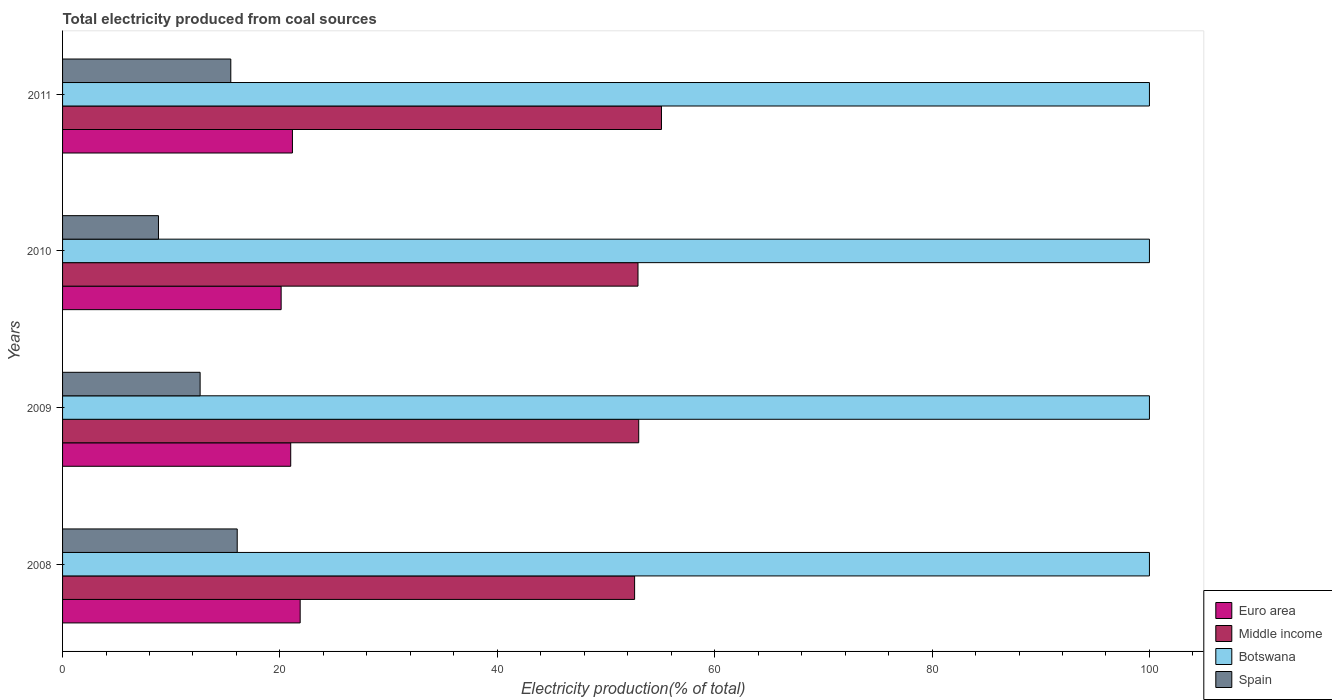Are the number of bars per tick equal to the number of legend labels?
Your answer should be compact. Yes. How many bars are there on the 1st tick from the top?
Your answer should be very brief. 4. How many bars are there on the 4th tick from the bottom?
Your response must be concise. 4. What is the label of the 3rd group of bars from the top?
Keep it short and to the point. 2009. What is the total electricity produced in Middle income in 2008?
Keep it short and to the point. 52.63. Across all years, what is the maximum total electricity produced in Botswana?
Provide a succinct answer. 100. Across all years, what is the minimum total electricity produced in Middle income?
Ensure brevity in your answer.  52.63. What is the total total electricity produced in Botswana in the graph?
Offer a terse response. 400. What is the difference between the total electricity produced in Euro area in 2008 and that in 2010?
Ensure brevity in your answer.  1.75. What is the difference between the total electricity produced in Spain in 2009 and the total electricity produced in Botswana in 2011?
Your answer should be very brief. -87.34. What is the average total electricity produced in Middle income per year?
Your response must be concise. 53.42. In the year 2011, what is the difference between the total electricity produced in Euro area and total electricity produced in Spain?
Ensure brevity in your answer.  5.67. What is the ratio of the total electricity produced in Middle income in 2010 to that in 2011?
Your response must be concise. 0.96. Is the difference between the total electricity produced in Euro area in 2009 and 2010 greater than the difference between the total electricity produced in Spain in 2009 and 2010?
Offer a terse response. No. What is the difference between the highest and the second highest total electricity produced in Euro area?
Offer a terse response. 0.71. What is the difference between the highest and the lowest total electricity produced in Spain?
Offer a terse response. 7.25. Is the sum of the total electricity produced in Middle income in 2008 and 2010 greater than the maximum total electricity produced in Euro area across all years?
Ensure brevity in your answer.  Yes. What does the 1st bar from the top in 2011 represents?
Provide a short and direct response. Spain. What does the 3rd bar from the bottom in 2008 represents?
Offer a terse response. Botswana. Is it the case that in every year, the sum of the total electricity produced in Botswana and total electricity produced in Spain is greater than the total electricity produced in Middle income?
Provide a short and direct response. Yes. How many bars are there?
Provide a short and direct response. 16. How many years are there in the graph?
Give a very brief answer. 4. Are the values on the major ticks of X-axis written in scientific E-notation?
Provide a short and direct response. No. Does the graph contain any zero values?
Keep it short and to the point. No. Does the graph contain grids?
Give a very brief answer. No. How many legend labels are there?
Your answer should be very brief. 4. What is the title of the graph?
Keep it short and to the point. Total electricity produced from coal sources. What is the label or title of the X-axis?
Offer a terse response. Electricity production(% of total). What is the Electricity production(% of total) in Euro area in 2008?
Provide a succinct answer. 21.86. What is the Electricity production(% of total) in Middle income in 2008?
Your answer should be very brief. 52.63. What is the Electricity production(% of total) of Botswana in 2008?
Make the answer very short. 100. What is the Electricity production(% of total) of Spain in 2008?
Offer a terse response. 16.07. What is the Electricity production(% of total) in Euro area in 2009?
Give a very brief answer. 20.99. What is the Electricity production(% of total) in Middle income in 2009?
Give a very brief answer. 53.01. What is the Electricity production(% of total) in Botswana in 2009?
Provide a short and direct response. 100. What is the Electricity production(% of total) of Spain in 2009?
Provide a short and direct response. 12.66. What is the Electricity production(% of total) in Euro area in 2010?
Provide a succinct answer. 20.11. What is the Electricity production(% of total) in Middle income in 2010?
Give a very brief answer. 52.94. What is the Electricity production(% of total) in Spain in 2010?
Keep it short and to the point. 8.82. What is the Electricity production(% of total) of Euro area in 2011?
Give a very brief answer. 21.15. What is the Electricity production(% of total) in Middle income in 2011?
Your response must be concise. 55.1. What is the Electricity production(% of total) of Spain in 2011?
Ensure brevity in your answer.  15.48. Across all years, what is the maximum Electricity production(% of total) of Euro area?
Provide a short and direct response. 21.86. Across all years, what is the maximum Electricity production(% of total) of Middle income?
Offer a very short reply. 55.1. Across all years, what is the maximum Electricity production(% of total) in Spain?
Offer a very short reply. 16.07. Across all years, what is the minimum Electricity production(% of total) in Euro area?
Offer a terse response. 20.11. Across all years, what is the minimum Electricity production(% of total) in Middle income?
Provide a short and direct response. 52.63. Across all years, what is the minimum Electricity production(% of total) in Botswana?
Make the answer very short. 100. Across all years, what is the minimum Electricity production(% of total) in Spain?
Keep it short and to the point. 8.82. What is the total Electricity production(% of total) in Euro area in the graph?
Offer a terse response. 84.11. What is the total Electricity production(% of total) of Middle income in the graph?
Provide a short and direct response. 213.69. What is the total Electricity production(% of total) in Botswana in the graph?
Your response must be concise. 400. What is the total Electricity production(% of total) of Spain in the graph?
Provide a short and direct response. 53.03. What is the difference between the Electricity production(% of total) of Euro area in 2008 and that in 2009?
Keep it short and to the point. 0.87. What is the difference between the Electricity production(% of total) in Middle income in 2008 and that in 2009?
Ensure brevity in your answer.  -0.38. What is the difference between the Electricity production(% of total) of Botswana in 2008 and that in 2009?
Offer a terse response. 0. What is the difference between the Electricity production(% of total) in Spain in 2008 and that in 2009?
Provide a short and direct response. 3.41. What is the difference between the Electricity production(% of total) in Euro area in 2008 and that in 2010?
Ensure brevity in your answer.  1.75. What is the difference between the Electricity production(% of total) in Middle income in 2008 and that in 2010?
Make the answer very short. -0.31. What is the difference between the Electricity production(% of total) in Botswana in 2008 and that in 2010?
Ensure brevity in your answer.  0. What is the difference between the Electricity production(% of total) in Spain in 2008 and that in 2010?
Make the answer very short. 7.25. What is the difference between the Electricity production(% of total) of Euro area in 2008 and that in 2011?
Ensure brevity in your answer.  0.71. What is the difference between the Electricity production(% of total) of Middle income in 2008 and that in 2011?
Your response must be concise. -2.47. What is the difference between the Electricity production(% of total) of Spain in 2008 and that in 2011?
Keep it short and to the point. 0.59. What is the difference between the Electricity production(% of total) in Euro area in 2009 and that in 2010?
Offer a terse response. 0.88. What is the difference between the Electricity production(% of total) of Middle income in 2009 and that in 2010?
Ensure brevity in your answer.  0.07. What is the difference between the Electricity production(% of total) of Spain in 2009 and that in 2010?
Offer a very short reply. 3.83. What is the difference between the Electricity production(% of total) in Euro area in 2009 and that in 2011?
Offer a very short reply. -0.16. What is the difference between the Electricity production(% of total) in Middle income in 2009 and that in 2011?
Make the answer very short. -2.09. What is the difference between the Electricity production(% of total) of Botswana in 2009 and that in 2011?
Provide a short and direct response. 0. What is the difference between the Electricity production(% of total) of Spain in 2009 and that in 2011?
Your answer should be very brief. -2.82. What is the difference between the Electricity production(% of total) in Euro area in 2010 and that in 2011?
Provide a succinct answer. -1.04. What is the difference between the Electricity production(% of total) in Middle income in 2010 and that in 2011?
Keep it short and to the point. -2.16. What is the difference between the Electricity production(% of total) of Spain in 2010 and that in 2011?
Ensure brevity in your answer.  -6.66. What is the difference between the Electricity production(% of total) in Euro area in 2008 and the Electricity production(% of total) in Middle income in 2009?
Give a very brief answer. -31.15. What is the difference between the Electricity production(% of total) of Euro area in 2008 and the Electricity production(% of total) of Botswana in 2009?
Your answer should be very brief. -78.14. What is the difference between the Electricity production(% of total) of Euro area in 2008 and the Electricity production(% of total) of Spain in 2009?
Make the answer very short. 9.21. What is the difference between the Electricity production(% of total) in Middle income in 2008 and the Electricity production(% of total) in Botswana in 2009?
Your response must be concise. -47.37. What is the difference between the Electricity production(% of total) in Middle income in 2008 and the Electricity production(% of total) in Spain in 2009?
Make the answer very short. 39.98. What is the difference between the Electricity production(% of total) of Botswana in 2008 and the Electricity production(% of total) of Spain in 2009?
Make the answer very short. 87.34. What is the difference between the Electricity production(% of total) in Euro area in 2008 and the Electricity production(% of total) in Middle income in 2010?
Ensure brevity in your answer.  -31.08. What is the difference between the Electricity production(% of total) of Euro area in 2008 and the Electricity production(% of total) of Botswana in 2010?
Offer a very short reply. -78.14. What is the difference between the Electricity production(% of total) in Euro area in 2008 and the Electricity production(% of total) in Spain in 2010?
Offer a very short reply. 13.04. What is the difference between the Electricity production(% of total) in Middle income in 2008 and the Electricity production(% of total) in Botswana in 2010?
Your answer should be very brief. -47.37. What is the difference between the Electricity production(% of total) of Middle income in 2008 and the Electricity production(% of total) of Spain in 2010?
Your answer should be compact. 43.81. What is the difference between the Electricity production(% of total) of Botswana in 2008 and the Electricity production(% of total) of Spain in 2010?
Ensure brevity in your answer.  91.18. What is the difference between the Electricity production(% of total) of Euro area in 2008 and the Electricity production(% of total) of Middle income in 2011?
Your response must be concise. -33.24. What is the difference between the Electricity production(% of total) in Euro area in 2008 and the Electricity production(% of total) in Botswana in 2011?
Ensure brevity in your answer.  -78.14. What is the difference between the Electricity production(% of total) in Euro area in 2008 and the Electricity production(% of total) in Spain in 2011?
Give a very brief answer. 6.38. What is the difference between the Electricity production(% of total) of Middle income in 2008 and the Electricity production(% of total) of Botswana in 2011?
Offer a very short reply. -47.37. What is the difference between the Electricity production(% of total) of Middle income in 2008 and the Electricity production(% of total) of Spain in 2011?
Ensure brevity in your answer.  37.15. What is the difference between the Electricity production(% of total) of Botswana in 2008 and the Electricity production(% of total) of Spain in 2011?
Your answer should be compact. 84.52. What is the difference between the Electricity production(% of total) in Euro area in 2009 and the Electricity production(% of total) in Middle income in 2010?
Your answer should be very brief. -31.95. What is the difference between the Electricity production(% of total) in Euro area in 2009 and the Electricity production(% of total) in Botswana in 2010?
Keep it short and to the point. -79.01. What is the difference between the Electricity production(% of total) of Euro area in 2009 and the Electricity production(% of total) of Spain in 2010?
Give a very brief answer. 12.17. What is the difference between the Electricity production(% of total) in Middle income in 2009 and the Electricity production(% of total) in Botswana in 2010?
Make the answer very short. -46.99. What is the difference between the Electricity production(% of total) of Middle income in 2009 and the Electricity production(% of total) of Spain in 2010?
Offer a terse response. 44.19. What is the difference between the Electricity production(% of total) in Botswana in 2009 and the Electricity production(% of total) in Spain in 2010?
Keep it short and to the point. 91.18. What is the difference between the Electricity production(% of total) of Euro area in 2009 and the Electricity production(% of total) of Middle income in 2011?
Offer a very short reply. -34.11. What is the difference between the Electricity production(% of total) in Euro area in 2009 and the Electricity production(% of total) in Botswana in 2011?
Give a very brief answer. -79.01. What is the difference between the Electricity production(% of total) in Euro area in 2009 and the Electricity production(% of total) in Spain in 2011?
Offer a terse response. 5.51. What is the difference between the Electricity production(% of total) in Middle income in 2009 and the Electricity production(% of total) in Botswana in 2011?
Offer a terse response. -46.99. What is the difference between the Electricity production(% of total) in Middle income in 2009 and the Electricity production(% of total) in Spain in 2011?
Your answer should be very brief. 37.53. What is the difference between the Electricity production(% of total) of Botswana in 2009 and the Electricity production(% of total) of Spain in 2011?
Your answer should be compact. 84.52. What is the difference between the Electricity production(% of total) of Euro area in 2010 and the Electricity production(% of total) of Middle income in 2011?
Your answer should be compact. -34.99. What is the difference between the Electricity production(% of total) of Euro area in 2010 and the Electricity production(% of total) of Botswana in 2011?
Provide a short and direct response. -79.89. What is the difference between the Electricity production(% of total) of Euro area in 2010 and the Electricity production(% of total) of Spain in 2011?
Your response must be concise. 4.63. What is the difference between the Electricity production(% of total) of Middle income in 2010 and the Electricity production(% of total) of Botswana in 2011?
Give a very brief answer. -47.06. What is the difference between the Electricity production(% of total) in Middle income in 2010 and the Electricity production(% of total) in Spain in 2011?
Provide a short and direct response. 37.46. What is the difference between the Electricity production(% of total) of Botswana in 2010 and the Electricity production(% of total) of Spain in 2011?
Your answer should be very brief. 84.52. What is the average Electricity production(% of total) in Euro area per year?
Your response must be concise. 21.03. What is the average Electricity production(% of total) in Middle income per year?
Offer a very short reply. 53.42. What is the average Electricity production(% of total) in Spain per year?
Keep it short and to the point. 13.26. In the year 2008, what is the difference between the Electricity production(% of total) in Euro area and Electricity production(% of total) in Middle income?
Make the answer very short. -30.77. In the year 2008, what is the difference between the Electricity production(% of total) in Euro area and Electricity production(% of total) in Botswana?
Ensure brevity in your answer.  -78.14. In the year 2008, what is the difference between the Electricity production(% of total) of Euro area and Electricity production(% of total) of Spain?
Keep it short and to the point. 5.79. In the year 2008, what is the difference between the Electricity production(% of total) of Middle income and Electricity production(% of total) of Botswana?
Your answer should be very brief. -47.37. In the year 2008, what is the difference between the Electricity production(% of total) in Middle income and Electricity production(% of total) in Spain?
Your answer should be compact. 36.56. In the year 2008, what is the difference between the Electricity production(% of total) in Botswana and Electricity production(% of total) in Spain?
Your response must be concise. 83.93. In the year 2009, what is the difference between the Electricity production(% of total) in Euro area and Electricity production(% of total) in Middle income?
Your answer should be very brief. -32.02. In the year 2009, what is the difference between the Electricity production(% of total) of Euro area and Electricity production(% of total) of Botswana?
Provide a short and direct response. -79.01. In the year 2009, what is the difference between the Electricity production(% of total) in Euro area and Electricity production(% of total) in Spain?
Your response must be concise. 8.34. In the year 2009, what is the difference between the Electricity production(% of total) in Middle income and Electricity production(% of total) in Botswana?
Your response must be concise. -46.99. In the year 2009, what is the difference between the Electricity production(% of total) of Middle income and Electricity production(% of total) of Spain?
Your answer should be compact. 40.35. In the year 2009, what is the difference between the Electricity production(% of total) in Botswana and Electricity production(% of total) in Spain?
Keep it short and to the point. 87.34. In the year 2010, what is the difference between the Electricity production(% of total) in Euro area and Electricity production(% of total) in Middle income?
Provide a short and direct response. -32.83. In the year 2010, what is the difference between the Electricity production(% of total) in Euro area and Electricity production(% of total) in Botswana?
Your answer should be compact. -79.89. In the year 2010, what is the difference between the Electricity production(% of total) in Euro area and Electricity production(% of total) in Spain?
Your answer should be very brief. 11.29. In the year 2010, what is the difference between the Electricity production(% of total) in Middle income and Electricity production(% of total) in Botswana?
Offer a terse response. -47.06. In the year 2010, what is the difference between the Electricity production(% of total) in Middle income and Electricity production(% of total) in Spain?
Your answer should be very brief. 44.12. In the year 2010, what is the difference between the Electricity production(% of total) in Botswana and Electricity production(% of total) in Spain?
Your answer should be compact. 91.18. In the year 2011, what is the difference between the Electricity production(% of total) of Euro area and Electricity production(% of total) of Middle income?
Ensure brevity in your answer.  -33.95. In the year 2011, what is the difference between the Electricity production(% of total) of Euro area and Electricity production(% of total) of Botswana?
Ensure brevity in your answer.  -78.85. In the year 2011, what is the difference between the Electricity production(% of total) of Euro area and Electricity production(% of total) of Spain?
Provide a succinct answer. 5.67. In the year 2011, what is the difference between the Electricity production(% of total) of Middle income and Electricity production(% of total) of Botswana?
Offer a very short reply. -44.9. In the year 2011, what is the difference between the Electricity production(% of total) in Middle income and Electricity production(% of total) in Spain?
Your answer should be compact. 39.62. In the year 2011, what is the difference between the Electricity production(% of total) in Botswana and Electricity production(% of total) in Spain?
Your answer should be very brief. 84.52. What is the ratio of the Electricity production(% of total) in Euro area in 2008 to that in 2009?
Provide a succinct answer. 1.04. What is the ratio of the Electricity production(% of total) in Spain in 2008 to that in 2009?
Your answer should be compact. 1.27. What is the ratio of the Electricity production(% of total) of Euro area in 2008 to that in 2010?
Your response must be concise. 1.09. What is the ratio of the Electricity production(% of total) in Middle income in 2008 to that in 2010?
Keep it short and to the point. 0.99. What is the ratio of the Electricity production(% of total) of Spain in 2008 to that in 2010?
Make the answer very short. 1.82. What is the ratio of the Electricity production(% of total) in Euro area in 2008 to that in 2011?
Give a very brief answer. 1.03. What is the ratio of the Electricity production(% of total) in Middle income in 2008 to that in 2011?
Offer a terse response. 0.96. What is the ratio of the Electricity production(% of total) in Botswana in 2008 to that in 2011?
Provide a short and direct response. 1. What is the ratio of the Electricity production(% of total) in Spain in 2008 to that in 2011?
Give a very brief answer. 1.04. What is the ratio of the Electricity production(% of total) in Euro area in 2009 to that in 2010?
Your answer should be very brief. 1.04. What is the ratio of the Electricity production(% of total) of Spain in 2009 to that in 2010?
Offer a terse response. 1.43. What is the ratio of the Electricity production(% of total) of Botswana in 2009 to that in 2011?
Offer a very short reply. 1. What is the ratio of the Electricity production(% of total) of Spain in 2009 to that in 2011?
Provide a short and direct response. 0.82. What is the ratio of the Electricity production(% of total) of Euro area in 2010 to that in 2011?
Ensure brevity in your answer.  0.95. What is the ratio of the Electricity production(% of total) in Middle income in 2010 to that in 2011?
Keep it short and to the point. 0.96. What is the ratio of the Electricity production(% of total) in Botswana in 2010 to that in 2011?
Ensure brevity in your answer.  1. What is the ratio of the Electricity production(% of total) in Spain in 2010 to that in 2011?
Your response must be concise. 0.57. What is the difference between the highest and the second highest Electricity production(% of total) in Euro area?
Your answer should be very brief. 0.71. What is the difference between the highest and the second highest Electricity production(% of total) in Middle income?
Provide a short and direct response. 2.09. What is the difference between the highest and the second highest Electricity production(% of total) in Botswana?
Offer a very short reply. 0. What is the difference between the highest and the second highest Electricity production(% of total) of Spain?
Keep it short and to the point. 0.59. What is the difference between the highest and the lowest Electricity production(% of total) of Euro area?
Keep it short and to the point. 1.75. What is the difference between the highest and the lowest Electricity production(% of total) of Middle income?
Offer a very short reply. 2.47. What is the difference between the highest and the lowest Electricity production(% of total) in Botswana?
Keep it short and to the point. 0. What is the difference between the highest and the lowest Electricity production(% of total) of Spain?
Give a very brief answer. 7.25. 